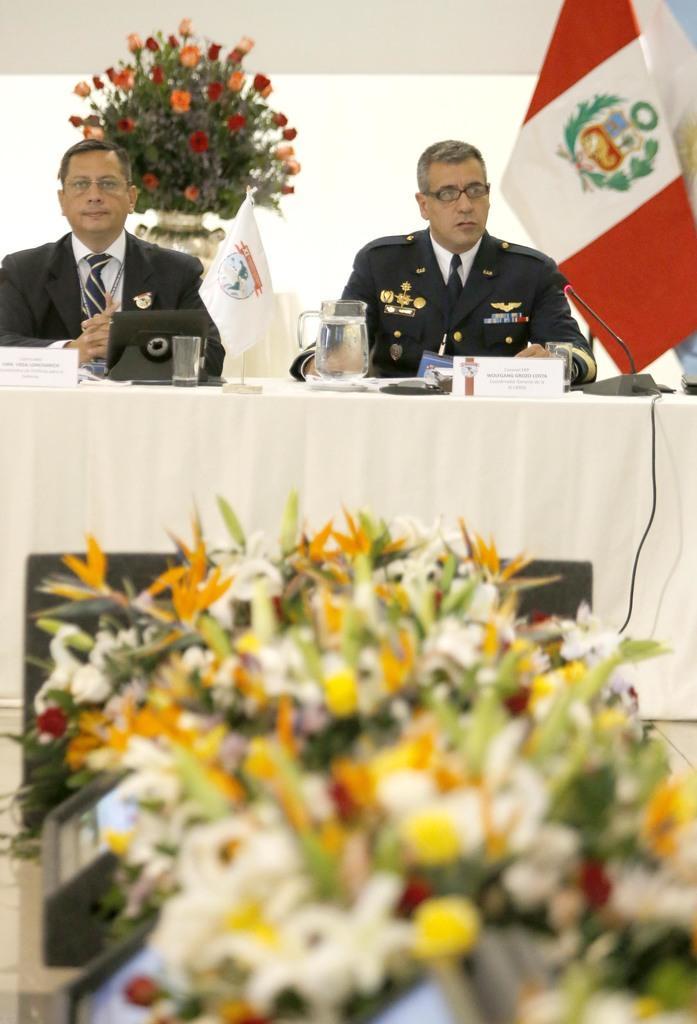In one or two sentences, can you explain what this image depicts? In this image we can see two persons sitting near the table covered with a cloth, there is a jug with water, a glass, boards, mic and few objects on the table, there is a flag, a house plant behind the persons, there are flowers and few objects in front of the table. 